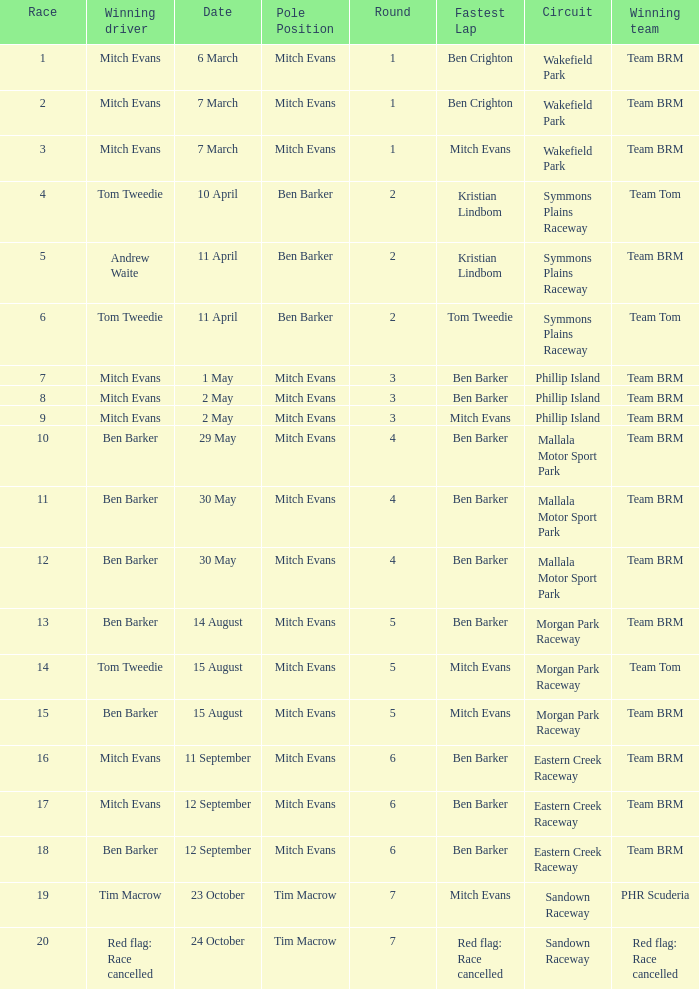In how many rounds was Race 17? 1.0. 